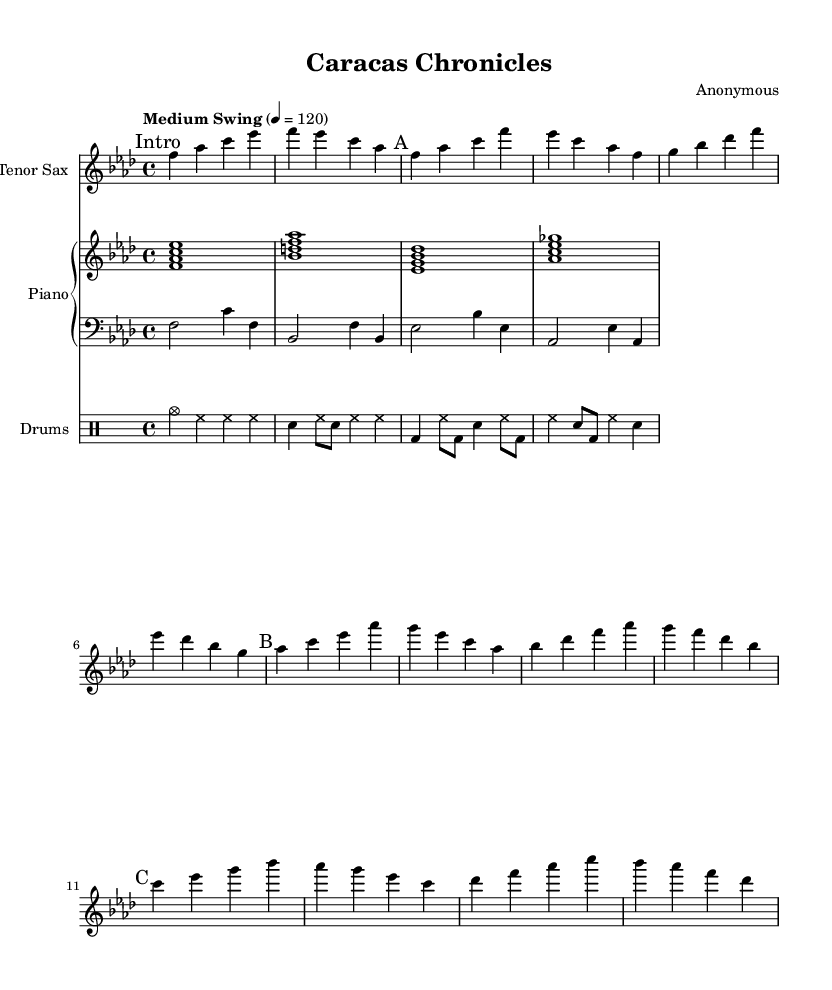What is the key signature of this music? The key signature shown at the beginning of the piece indicates that it is in F minor, as it has four flats (B♭, E♭, A♭, and D♭) which are standard for this key.
Answer: F minor What is the time signature of this music? The time signature is indicated at the beginning of the score. It shows a 4/4 signature, meaning there are four beats per measure, and each beat is a quarter note.
Answer: 4/4 What is the tempo marking of the music? The tempo marking is found above the first measure and it states "Medium Swing," which suggests a relaxed tempo that is characteristic of jazz music, with a specific metronome marking of 120 beats per minute.
Answer: Medium Swing What instruments are featured in this composition? The composition features a tenor saxophone, piano, bass, and drums, as indicated by the respective staff names.
Answer: Tenor Saxophone, Piano, Bass, Drums How many sections are there in the saxophone part? The saxophone part is divided into four sections labeled "Intro," "A," "B," and "C," making a total of four distinct sections presented in the score.
Answer: 4 What is the rhythmic pattern used in the drum part? The drum part primarily utilizes a swing rhythm, particularly evident in the hi-hat and snare, which is typical of jazz drumming to provide a groovy feel. The pattern alternates between cymbals and snare with eighth notes.
Answer: Swing rhythm What is a characteristic feature of the jazz style present in this composition? The composition employs syncopation in the saxophone and rhythmic accents in the drum part, which are hallmark traits of jazz music, adding a lively, unpredictable feel that engages the listener.
Answer: Syncopation 